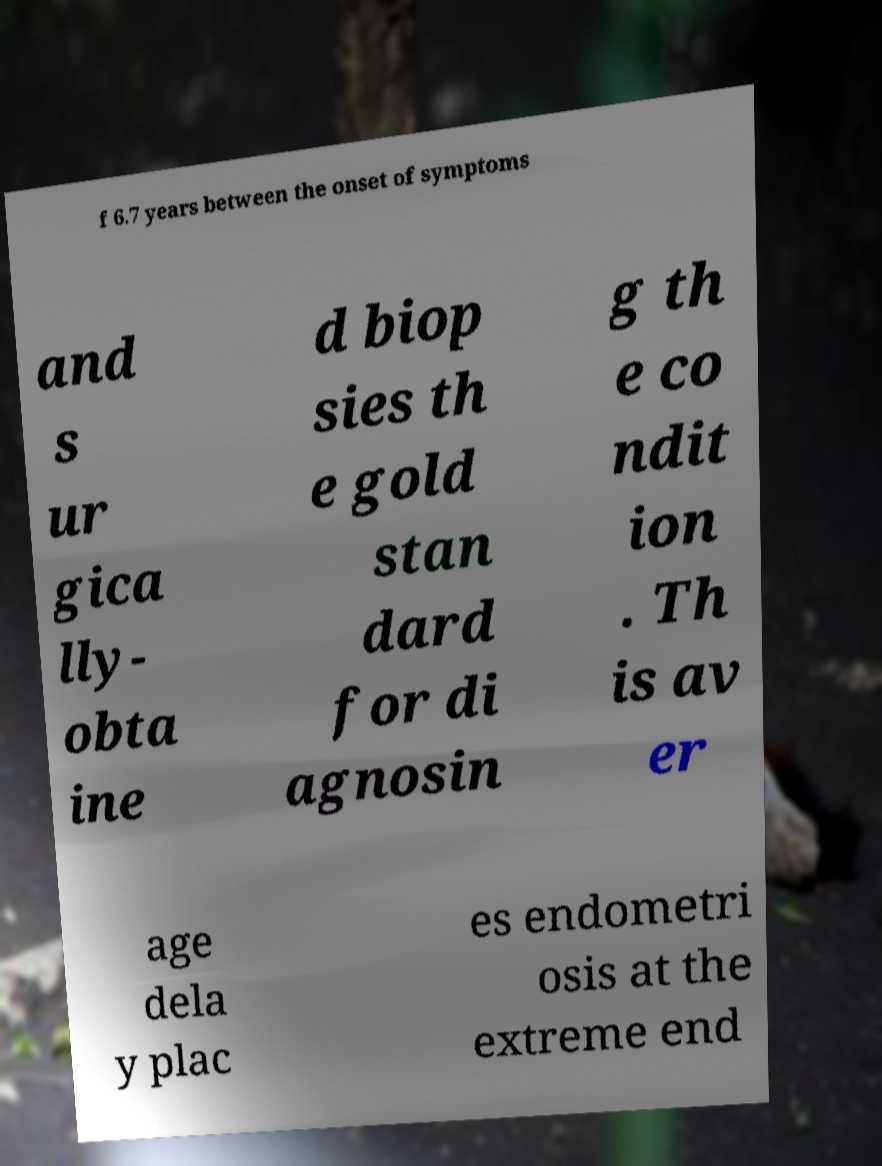Can you accurately transcribe the text from the provided image for me? f 6.7 years between the onset of symptoms and s ur gica lly- obta ine d biop sies th e gold stan dard for di agnosin g th e co ndit ion . Th is av er age dela y plac es endometri osis at the extreme end 